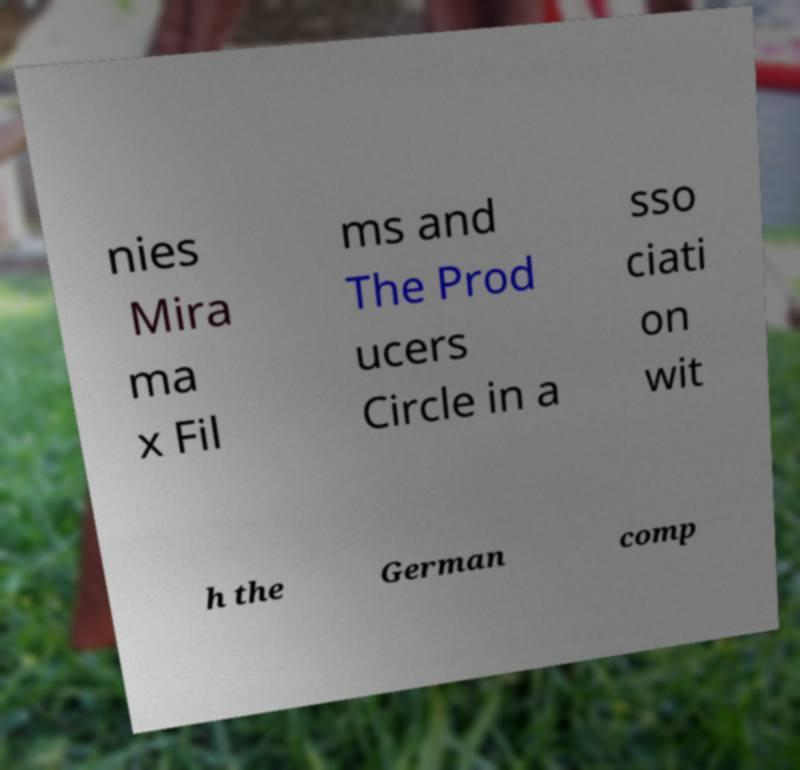Could you extract and type out the text from this image? nies Mira ma x Fil ms and The Prod ucers Circle in a sso ciati on wit h the German comp 